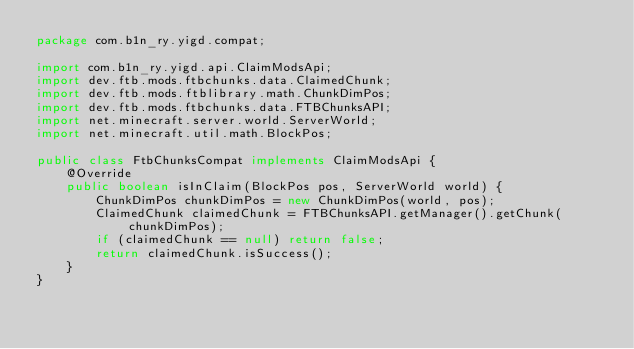Convert code to text. <code><loc_0><loc_0><loc_500><loc_500><_Java_>package com.b1n_ry.yigd.compat;

import com.b1n_ry.yigd.api.ClaimModsApi;
import dev.ftb.mods.ftbchunks.data.ClaimedChunk;
import dev.ftb.mods.ftblibrary.math.ChunkDimPos;
import dev.ftb.mods.ftbchunks.data.FTBChunksAPI;
import net.minecraft.server.world.ServerWorld;
import net.minecraft.util.math.BlockPos;

public class FtbChunksCompat implements ClaimModsApi {
    @Override
    public boolean isInClaim(BlockPos pos, ServerWorld world) {
        ChunkDimPos chunkDimPos = new ChunkDimPos(world, pos);
        ClaimedChunk claimedChunk = FTBChunksAPI.getManager().getChunk(chunkDimPos);
        if (claimedChunk == null) return false;
        return claimedChunk.isSuccess();
    }
}
</code> 